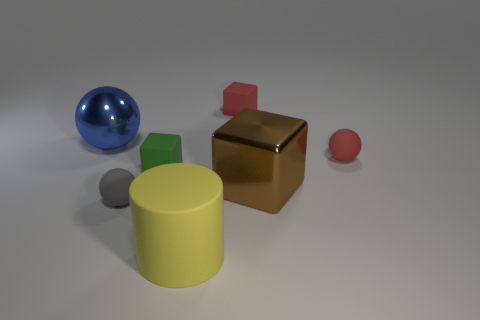Add 2 tiny red balls. How many objects exist? 9 Subtract all balls. How many objects are left? 4 Add 1 purple metal things. How many purple metal things exist? 1 Subtract 1 brown cubes. How many objects are left? 6 Subtract all tiny blue metallic blocks. Subtract all yellow rubber objects. How many objects are left? 6 Add 7 big objects. How many big objects are left? 10 